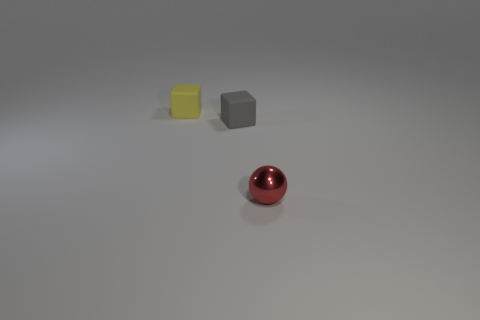Is there anything else that has the same material as the ball?
Your answer should be very brief. No. How many purple things are either small balls or rubber objects?
Provide a succinct answer. 0. Is there a brown metal object that has the same size as the red thing?
Provide a short and direct response. No. The cube that is right of the matte object behind the small matte object to the right of the yellow rubber object is made of what material?
Your response must be concise. Rubber. Is the number of tiny yellow matte blocks on the right side of the small gray rubber cube the same as the number of small gray objects?
Your answer should be compact. No. Is the material of the small object that is behind the tiny gray object the same as the object that is in front of the gray rubber object?
Your answer should be very brief. No. What number of objects are either big brown rubber cylinders or things that are on the right side of the yellow matte object?
Keep it short and to the point. 2. Are there any large red matte things of the same shape as the tiny gray thing?
Offer a very short reply. No. What size is the cube that is behind the matte block that is to the right of the matte thing behind the small gray matte cube?
Offer a terse response. Small. Is the number of yellow cubes that are left of the ball the same as the number of tiny red shiny things that are in front of the small gray matte block?
Your answer should be very brief. Yes. 